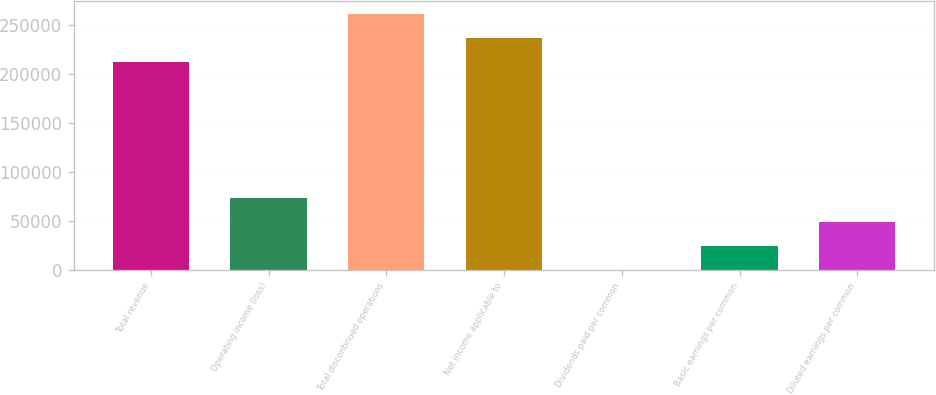Convert chart to OTSL. <chart><loc_0><loc_0><loc_500><loc_500><bar_chart><fcel>Total revenue<fcel>Operating income (loss)<fcel>Total discontinued operations<fcel>Net income applicable to<fcel>Dividends paid per common<fcel>Basic earnings per common<fcel>Diluted earnings per common<nl><fcel>212758<fcel>73006.8<fcel>261429<fcel>237093<fcel>0.42<fcel>24335.9<fcel>48671.3<nl></chart> 